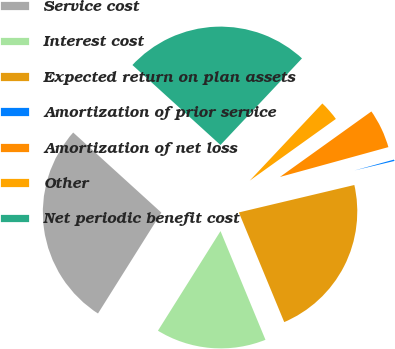<chart> <loc_0><loc_0><loc_500><loc_500><pie_chart><fcel>Service cost<fcel>Interest cost<fcel>Expected return on plan assets<fcel>Amortization of prior service<fcel>Amortization of net loss<fcel>Other<fcel>Net periodic benefit cost<nl><fcel>27.81%<fcel>15.17%<fcel>22.47%<fcel>0.56%<fcel>5.62%<fcel>3.09%<fcel>25.28%<nl></chart> 